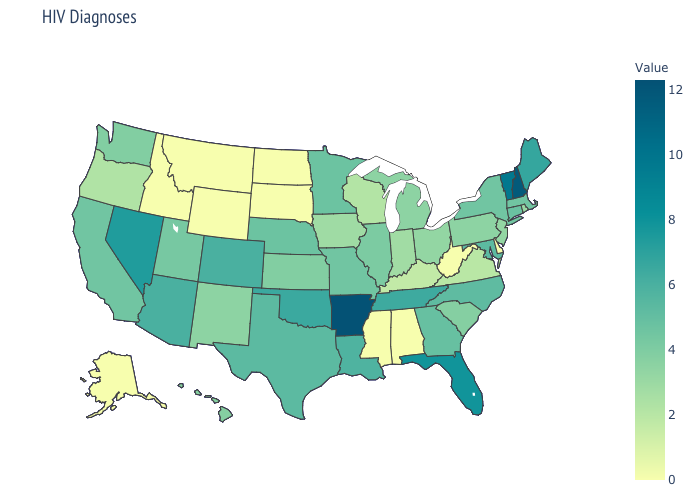Does Indiana have a lower value than West Virginia?
Give a very brief answer. No. Among the states that border Connecticut , which have the lowest value?
Short answer required. Rhode Island. Which states hav the highest value in the Northeast?
Quick response, please. New Hampshire. Does Nevada have the highest value in the West?
Answer briefly. Yes. Does Indiana have a higher value than Wyoming?
Answer briefly. Yes. Among the states that border Rhode Island , does Massachusetts have the lowest value?
Be succinct. Yes. Which states have the lowest value in the Northeast?
Give a very brief answer. Rhode Island. Does Kansas have the highest value in the MidWest?
Short answer required. No. Among the states that border Indiana , does Kentucky have the lowest value?
Answer briefly. Yes. Does Montana have the lowest value in the USA?
Give a very brief answer. Yes. 